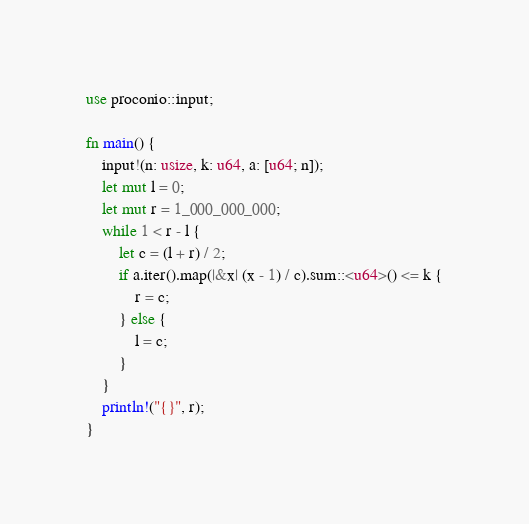Convert code to text. <code><loc_0><loc_0><loc_500><loc_500><_Rust_>use proconio::input;

fn main() {
    input!(n: usize, k: u64, a: [u64; n]);
    let mut l = 0;
    let mut r = 1_000_000_000;
    while 1 < r - l {
        let c = (l + r) / 2;
        if a.iter().map(|&x| (x - 1) / c).sum::<u64>() <= k {
            r = c;
        } else {
            l = c;
        }
    }
    println!("{}", r);
}
</code> 